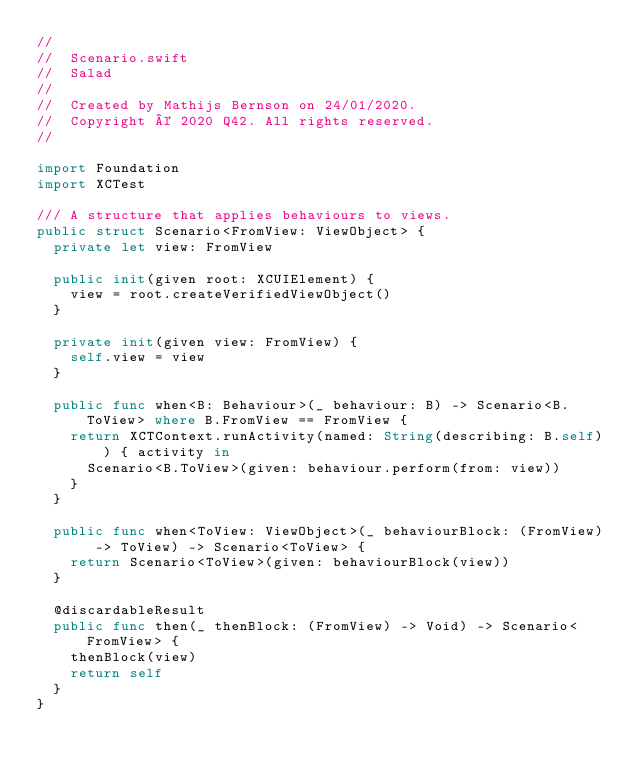<code> <loc_0><loc_0><loc_500><loc_500><_Swift_>//
//  Scenario.swift
//  Salad
//
//  Created by Mathijs Bernson on 24/01/2020.
//  Copyright © 2020 Q42. All rights reserved.
//

import Foundation
import XCTest

/// A structure that applies behaviours to views.
public struct Scenario<FromView: ViewObject> {
  private let view: FromView

  public init(given root: XCUIElement) {
    view = root.createVerifiedViewObject()
  }

  private init(given view: FromView) {
    self.view = view
  }

  public func when<B: Behaviour>(_ behaviour: B) -> Scenario<B.ToView> where B.FromView == FromView {
    return XCTContext.runActivity(named: String(describing: B.self)) { activity in
      Scenario<B.ToView>(given: behaviour.perform(from: view))
    }
  }

  public func when<ToView: ViewObject>(_ behaviourBlock: (FromView) -> ToView) -> Scenario<ToView> {
    return Scenario<ToView>(given: behaviourBlock(view))
  }

  @discardableResult
  public func then(_ thenBlock: (FromView) -> Void) -> Scenario<FromView> {
    thenBlock(view)
    return self
  }
}
</code> 